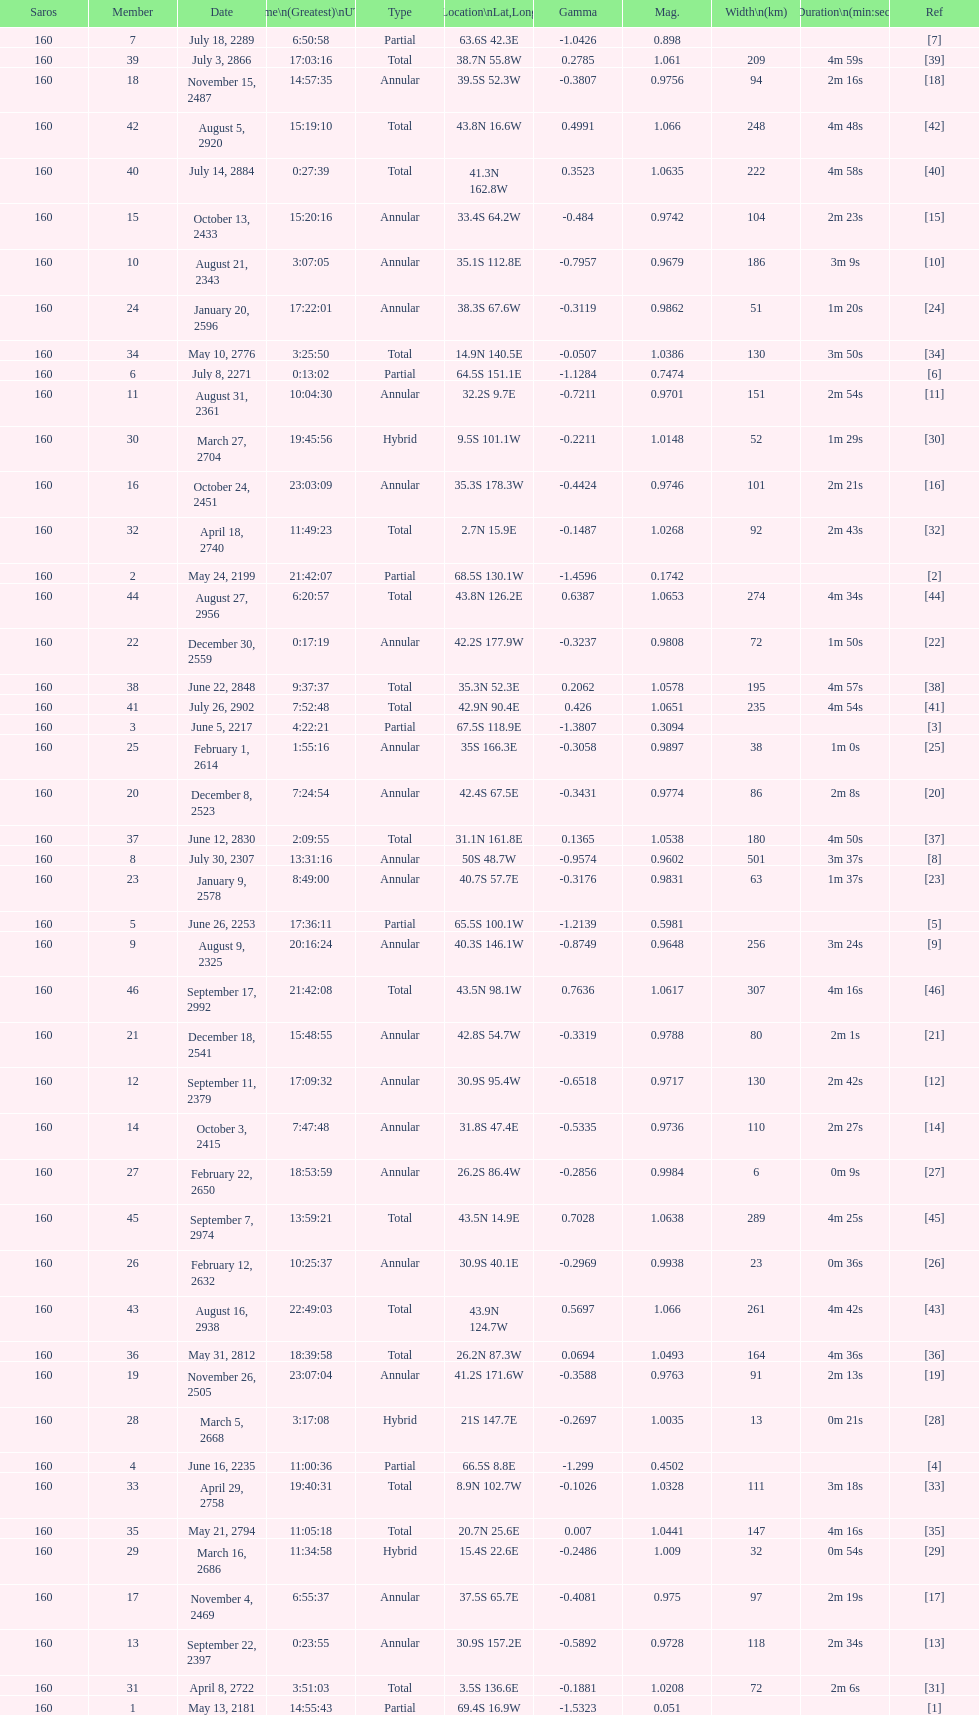How many partial members will occur before the first annular? 7. 